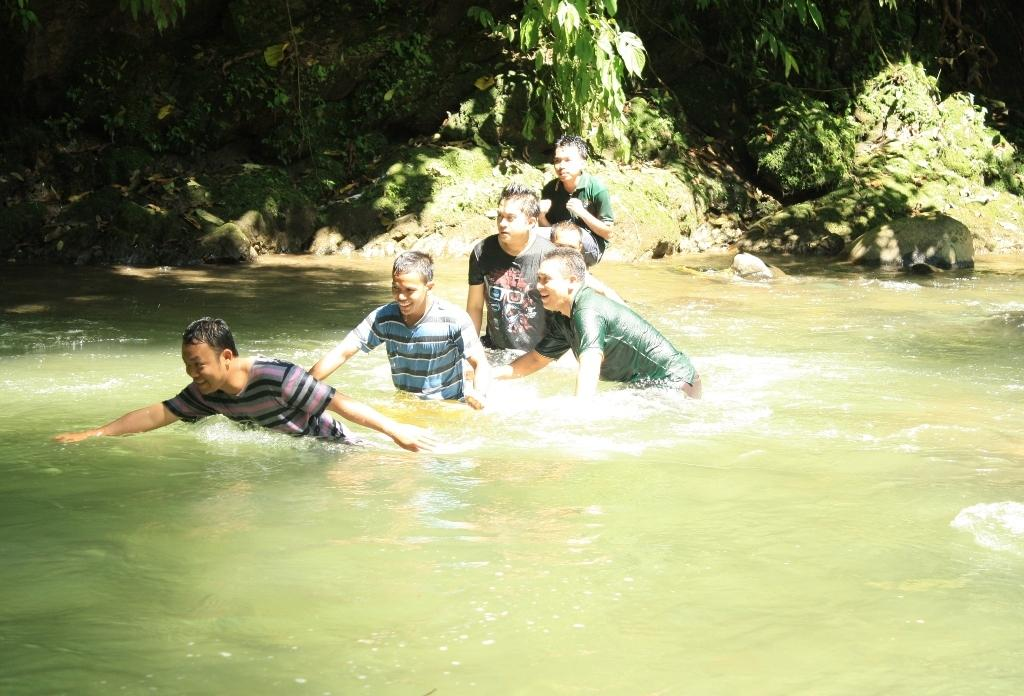What is happening in the pond in the image? There are people in the pond in the image. What can be seen behind the pond? There are trees, plants, and rocks behind the pond in the image. How many clocks are hanging from the trees behind the pond? There are no clocks visible in the image; only trees, plants, and rocks can be seen behind the pond. 